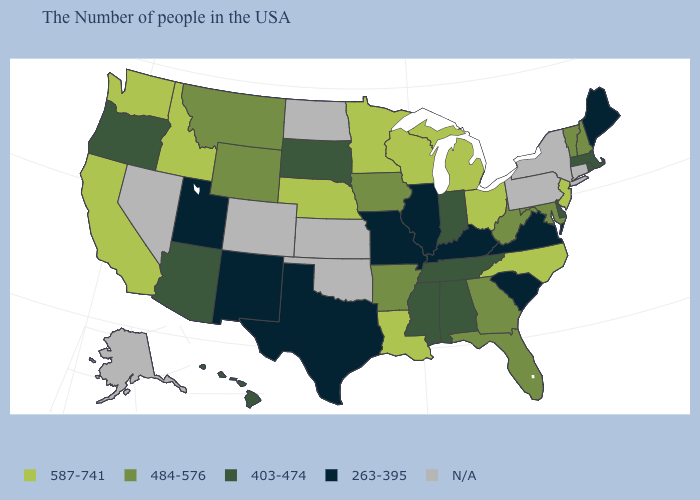How many symbols are there in the legend?
Answer briefly. 5. What is the value of Oklahoma?
Concise answer only. N/A. Name the states that have a value in the range N/A?
Keep it brief. Connecticut, New York, Pennsylvania, Kansas, Oklahoma, North Dakota, Colorado, Nevada, Alaska. What is the value of Maryland?
Be succinct. 484-576. What is the value of Colorado?
Write a very short answer. N/A. Does the first symbol in the legend represent the smallest category?
Give a very brief answer. No. What is the lowest value in the USA?
Give a very brief answer. 263-395. What is the value of Oregon?
Concise answer only. 403-474. Among the states that border Montana , which have the highest value?
Write a very short answer. Idaho. What is the value of New York?
Give a very brief answer. N/A. Name the states that have a value in the range 587-741?
Concise answer only. New Jersey, North Carolina, Ohio, Michigan, Wisconsin, Louisiana, Minnesota, Nebraska, Idaho, California, Washington. What is the value of Utah?
Quick response, please. 263-395. What is the highest value in the USA?
Answer briefly. 587-741. Is the legend a continuous bar?
Be succinct. No. What is the lowest value in the USA?
Concise answer only. 263-395. 